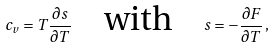Convert formula to latex. <formula><loc_0><loc_0><loc_500><loc_500>c _ { v } = T \frac { \partial s } { \partial T } \quad \text {with} \quad s = - \frac { \partial F } { \partial T } \, ,</formula> 